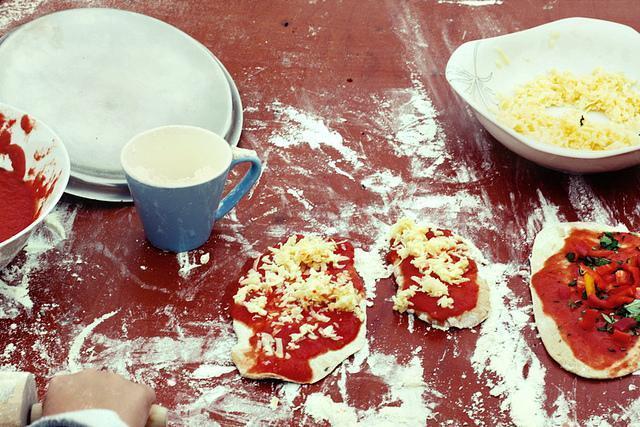How many cups are in the picture?
Give a very brief answer. 1. How many pizzas are in the photo?
Give a very brief answer. 3. How many bowls are in the photo?
Give a very brief answer. 2. How many chairs are to the left of the woman?
Give a very brief answer. 0. 